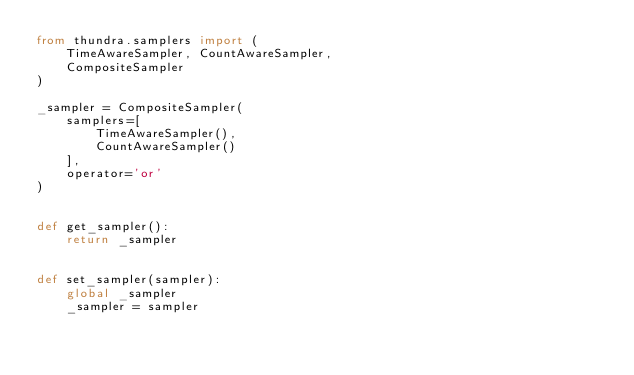Convert code to text. <code><loc_0><loc_0><loc_500><loc_500><_Python_>from thundra.samplers import (
    TimeAwareSampler, CountAwareSampler,
    CompositeSampler
)

_sampler = CompositeSampler(
    samplers=[
        TimeAwareSampler(),
        CountAwareSampler()
    ],
    operator='or'
)


def get_sampler():
    return _sampler


def set_sampler(sampler):
    global _sampler
    _sampler = sampler
</code> 